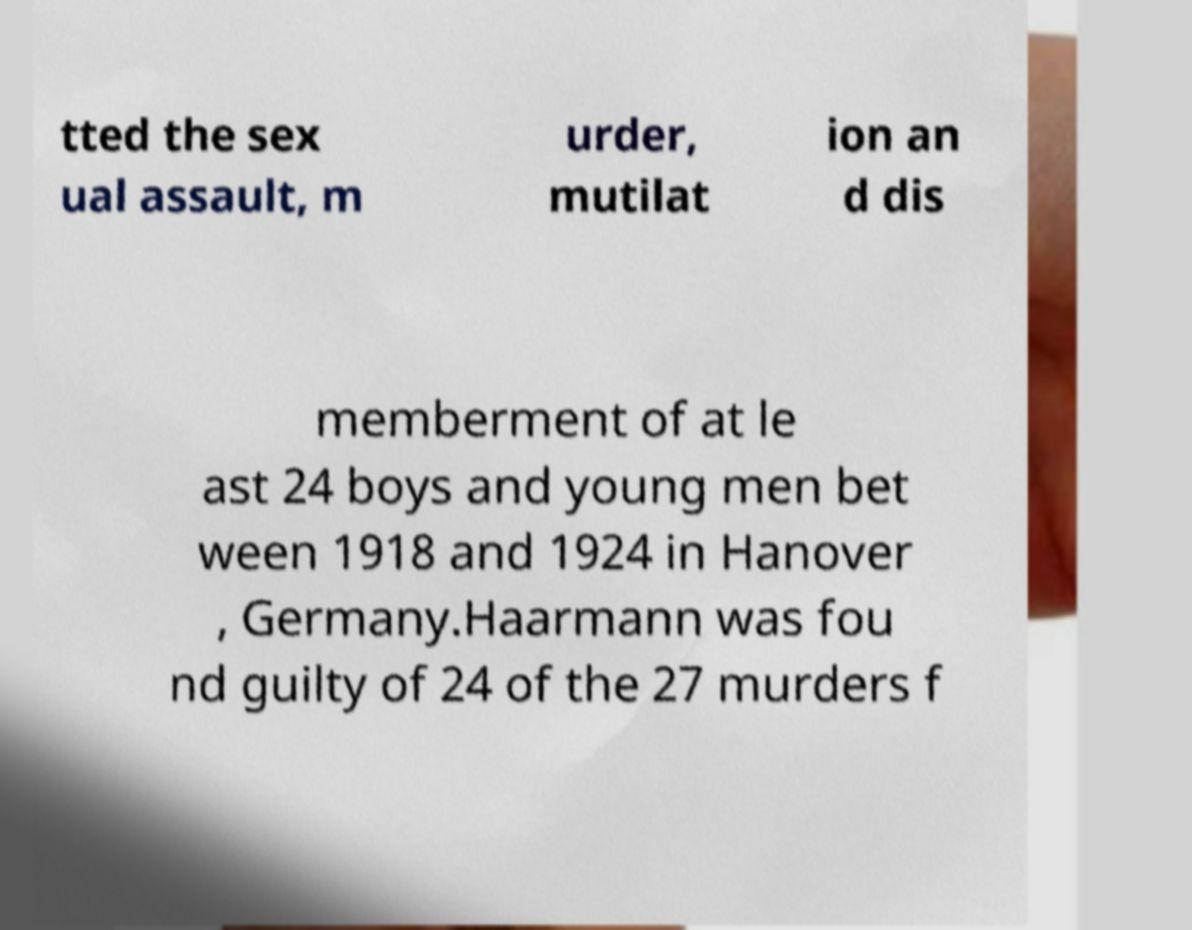There's text embedded in this image that I need extracted. Can you transcribe it verbatim? tted the sex ual assault, m urder, mutilat ion an d dis memberment of at le ast 24 boys and young men bet ween 1918 and 1924 in Hanover , Germany.Haarmann was fou nd guilty of 24 of the 27 murders f 